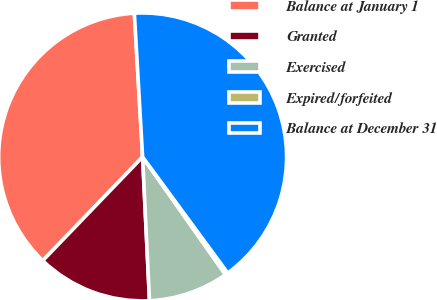Convert chart. <chart><loc_0><loc_0><loc_500><loc_500><pie_chart><fcel>Balance at January 1<fcel>Granted<fcel>Exercised<fcel>Expired/forfeited<fcel>Balance at December 31<nl><fcel>36.89%<fcel>12.96%<fcel>9.0%<fcel>0.31%<fcel>40.84%<nl></chart> 